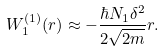Convert formula to latex. <formula><loc_0><loc_0><loc_500><loc_500>W _ { 1 } ^ { ( 1 ) } ( r ) \approx - \frac { \hbar { N } _ { 1 } \delta ^ { 2 } } { 2 \sqrt { 2 m } } r .</formula> 